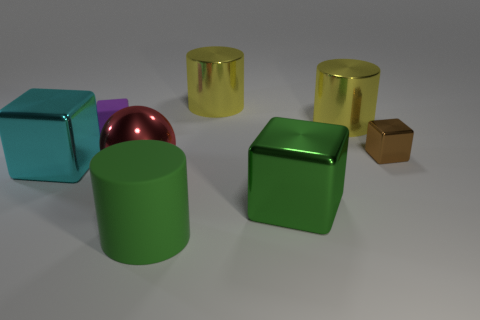Is there a cylinder that has the same color as the big metallic ball?
Provide a short and direct response. No. Are there any big metal things left of the large metal object in front of the sphere?
Offer a terse response. Yes. Is there a large green object that has the same material as the large red thing?
Keep it short and to the point. Yes. There is a block that is on the left side of the small object behind the tiny brown block; what is its material?
Provide a succinct answer. Metal. There is a thing that is both behind the big green cylinder and in front of the big red sphere; what is it made of?
Your answer should be very brief. Metal. Is the number of yellow metallic objects that are on the left side of the matte block the same as the number of big cylinders?
Your answer should be very brief. No. What number of other matte objects have the same shape as the brown object?
Offer a very short reply. 1. What is the size of the green thing that is behind the cylinder in front of the big shiny thing on the left side of the tiny purple object?
Your response must be concise. Large. Do the cylinder that is in front of the green block and the tiny purple thing have the same material?
Keep it short and to the point. Yes. Is the number of green cylinders to the left of the cyan shiny cube the same as the number of things that are in front of the green matte cylinder?
Offer a terse response. Yes. 